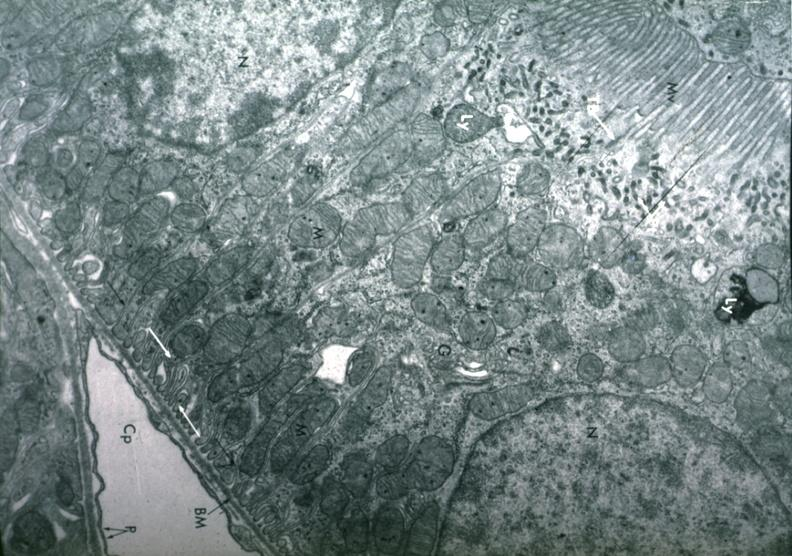where is this?
Answer the question using a single word or phrase. Urinary 